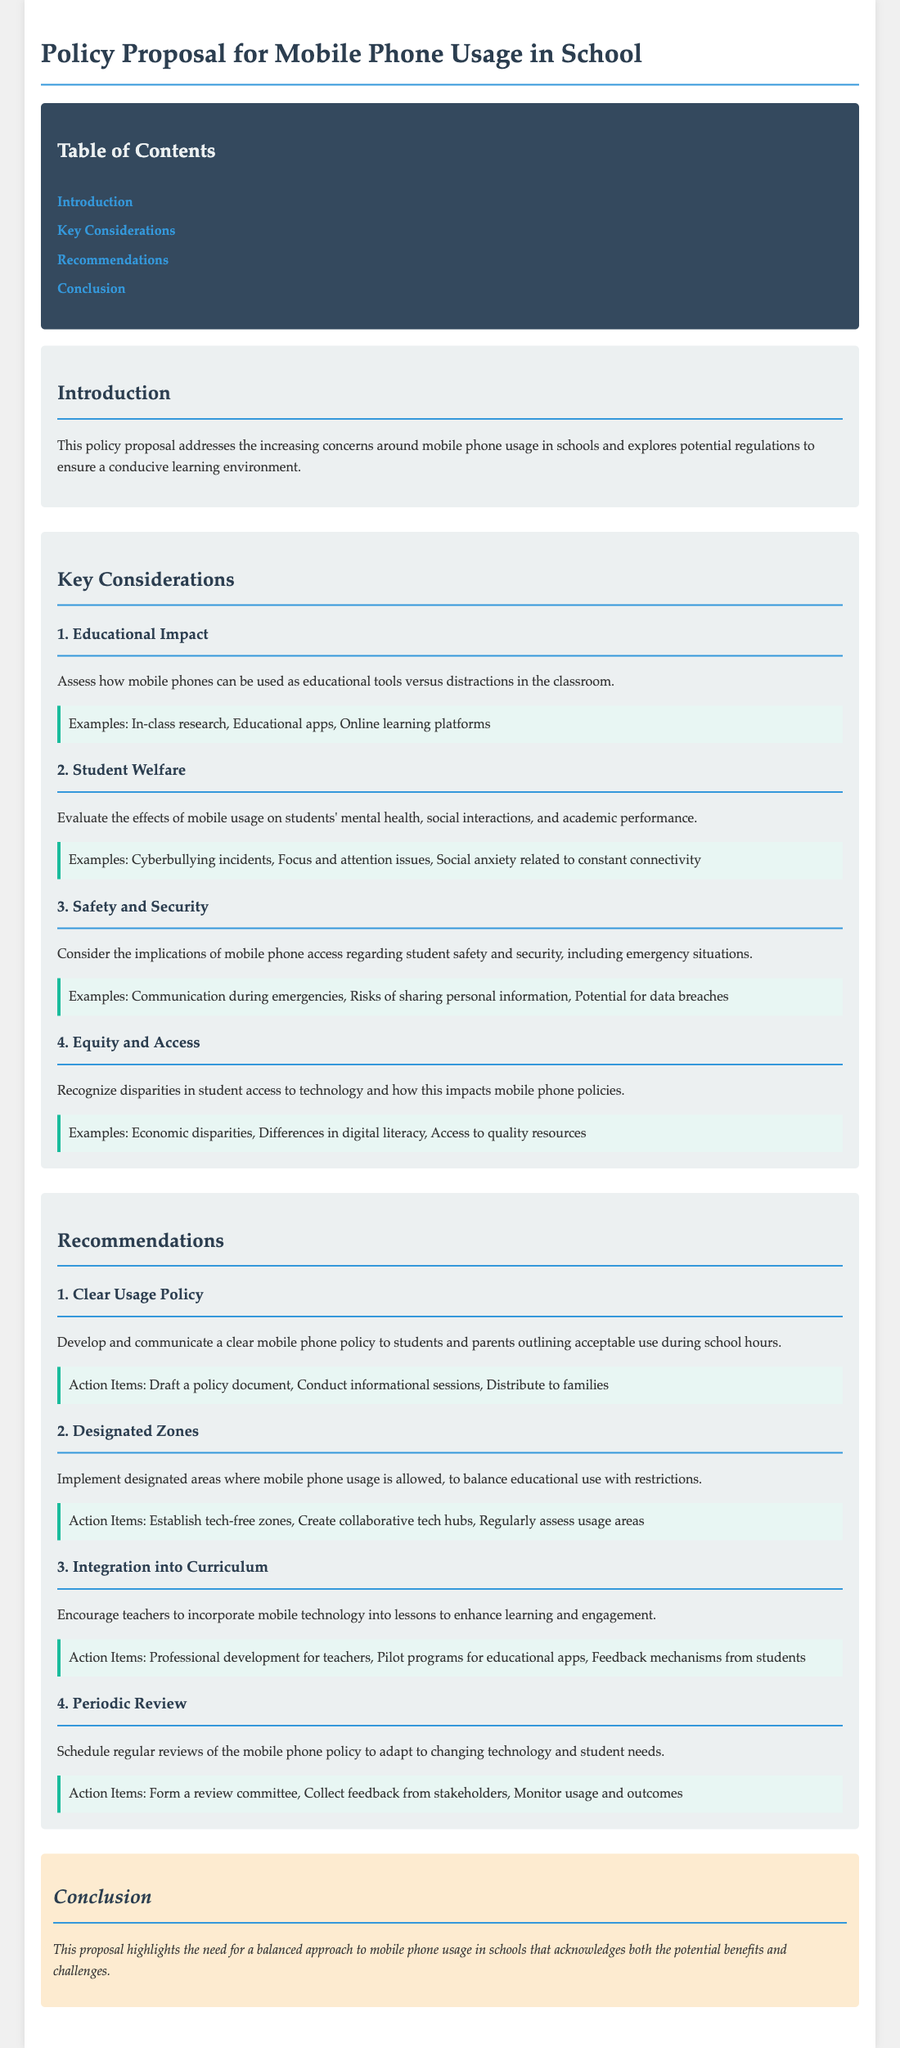What is the title of the document? The title is stated at the top of the document as the main heading.
Answer: Policy Proposal for Mobile Phone Usage in School What is one of the key considerations regarding student welfare? The document lists various points under each consideration; one specific concern is mentioned in the student welfare section.
Answer: Mental health How many recommendations are included in the proposal? The document outlines specific recommendations within its recommendations section, which can be counted.
Answer: Four What does the introduction address? The introduction focuses on particular concerns related to mobile phone usage in the school environment.
Answer: Concerns around mobile phone usage Which section contains action items for implementing a clear usage policy? The action items are detailed under specific recommendations; identifying the corresponding section will reveal the answer.
Answer: Recommendations What example mentions risks associated with mobile phone access? The examples under the safety and security consideration provide specific instances related to risks.
Answer: Data breaches What is one suggested action item for designated zones? Each section on recommendations includes actionable steps; one will pertain specifically to designated zones.
Answer: Establish tech-free zones What is the conclusion's primary emphasis? The conclusion summarizes the overall focus of the proposal and reflects on mobile phone usage.
Answer: Balanced approach 